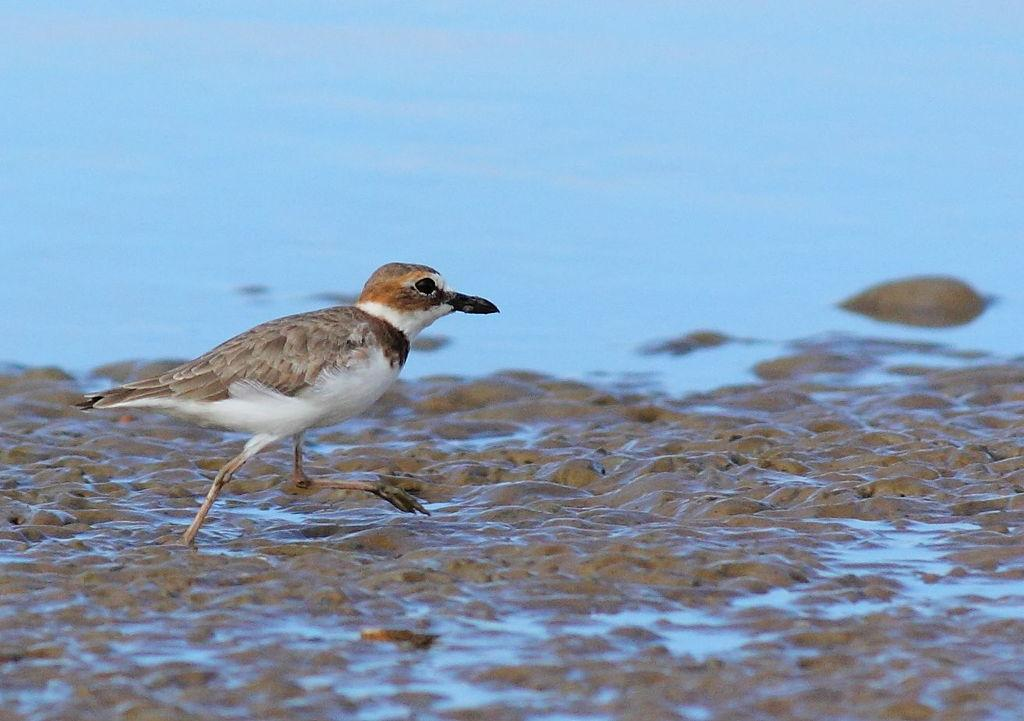What is the main subject in the center of the image? There is a bird in the center of the image. What type of surface is visible at the bottom of the image? There is sand at the bottom of the image. What scientific experiment is being conducted with the bird in the image? There is no indication of a scientific experiment being conducted in the image; it simply shows a bird in the center of the image. 